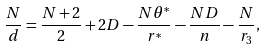Convert formula to latex. <formula><loc_0><loc_0><loc_500><loc_500>\frac { N } { d } = \frac { N + 2 } { 2 } + 2 D - \frac { N \theta ^ { * } } { r ^ { * } } - \frac { N D } { n } - \frac { N } { r _ { 3 } } ,</formula> 